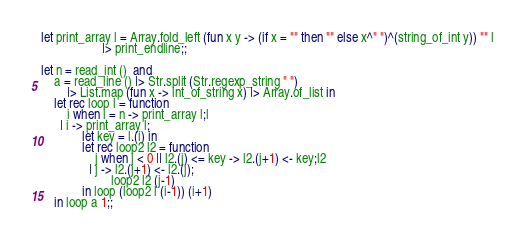Convert code to text. <code><loc_0><loc_0><loc_500><loc_500><_OCaml_>let print_array l = Array.fold_left (fun x y -> (if x = "" then "" else x^" ")^(string_of_int y)) "" l
                   |> print_endline;;

let n = read_int ()  and
    a = read_line () |> Str.split (Str.regexp_string " ")
        |> List.map (fun x -> int_of_string x) |> Array.of_list in
    let rec loop l = function
        i when i = n -> print_array l;l
      | i -> print_array l;
             let key = l.(i) in
             let rec loop2 l2 = function
                 j when j < 0 || l2.(j) <= key -> l2.(j+1) <- key;l2
               | j -> l2.(j+1) <- l2.(j);
                      loop2 l2 (j-1)
             in loop (loop2 l (i-1)) (i+1)
    in loop a 1;;</code> 